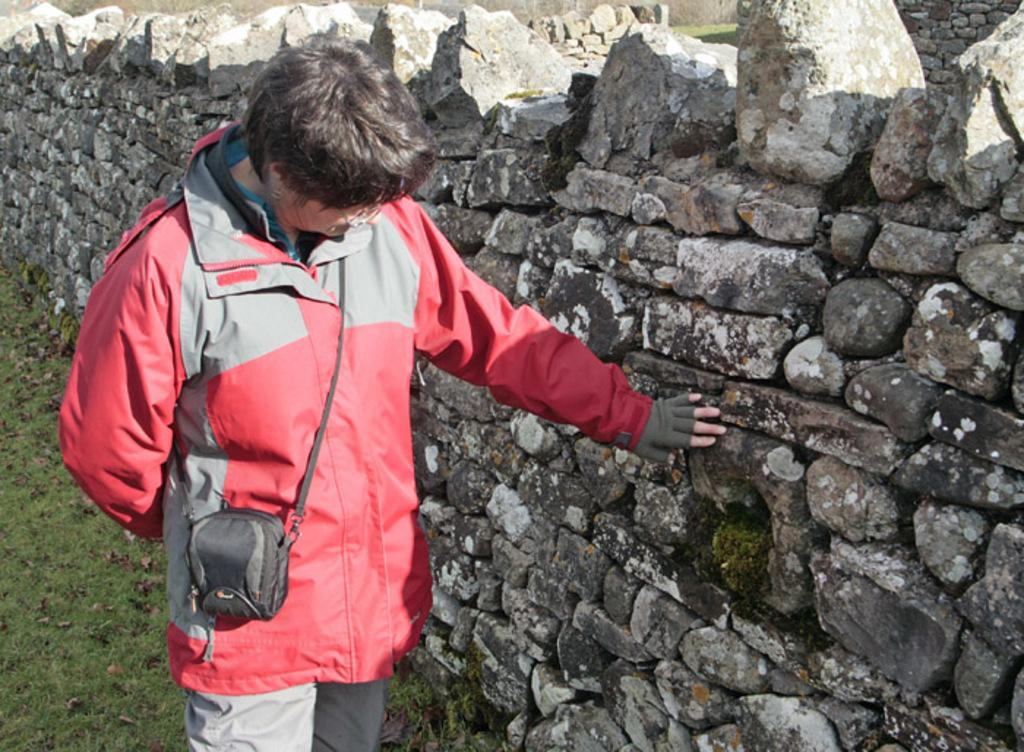Who or what is in the image? There is a person in the image. What is the person holding or carrying? The person is carrying a bag. What can be seen behind the person? There is a wall visible behind the person. What is present on the ground in the image? Dried leaves are present on the grass. What can be seen in the distance in the image? Stones are visible in the background of the image. What type of voice can be heard coming from the shelf in the image? There is no shelf present in the image, and therefore no voice can be heard coming from it. 